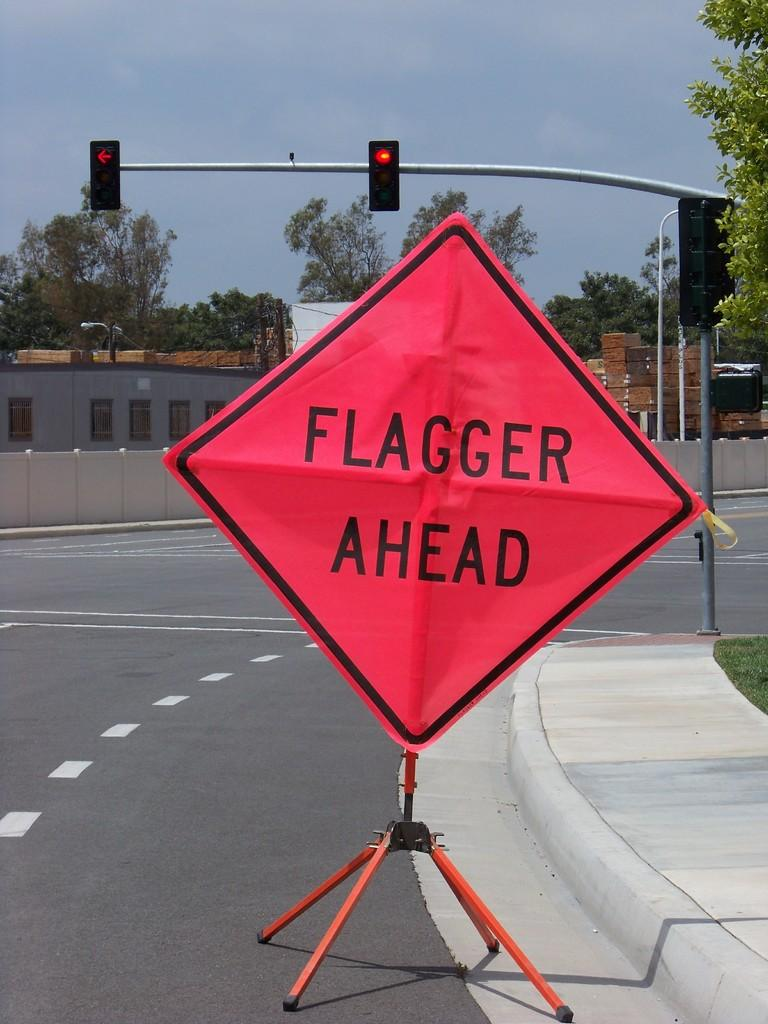<image>
Present a compact description of the photo's key features. An orange construction sign reads "flagger ahead" and is set up on a street. 